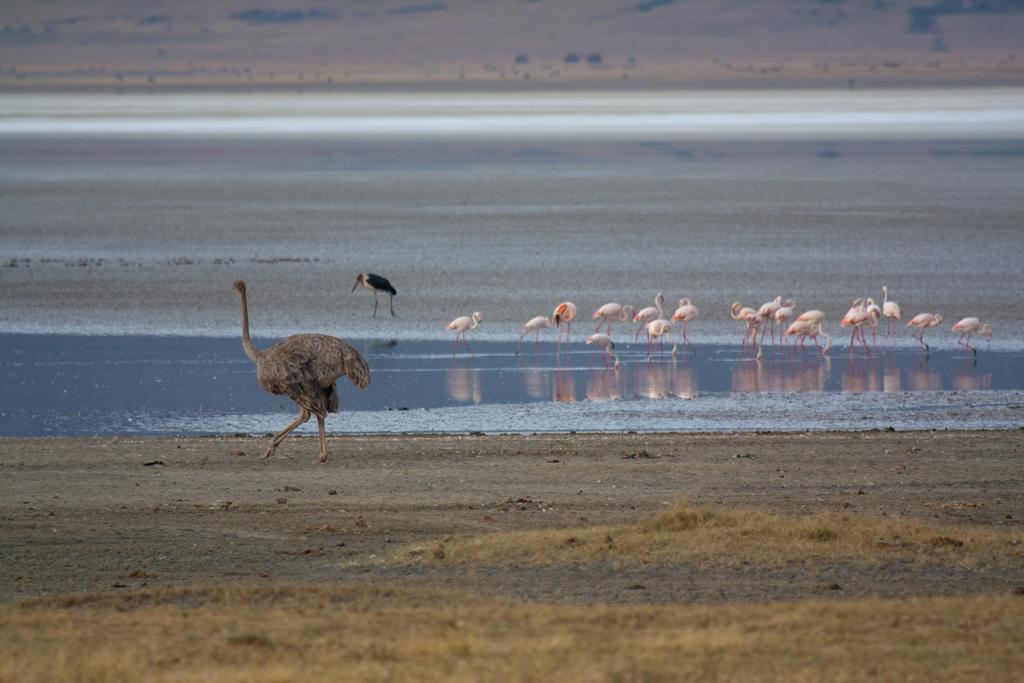Where was the image taken? The image was clicked near a water body. What animals can be seen in the center of the image? There are flamingos, a crane, and an ostrich in the center of the image. What type of terrain is present in the center of the image? Soil is present in the center of the image. What natural element is visible in the center of the image? Water is visible in the center of the image. How is the background of the image depicted? The background of the image is blurred. What type of locket is the girl wearing in the image? There are no girls present in the image, so there is no locket to be seen. What account number is visible on the ostrich's wing in the image? There is no account number present on the ostrich's wing in the image. 